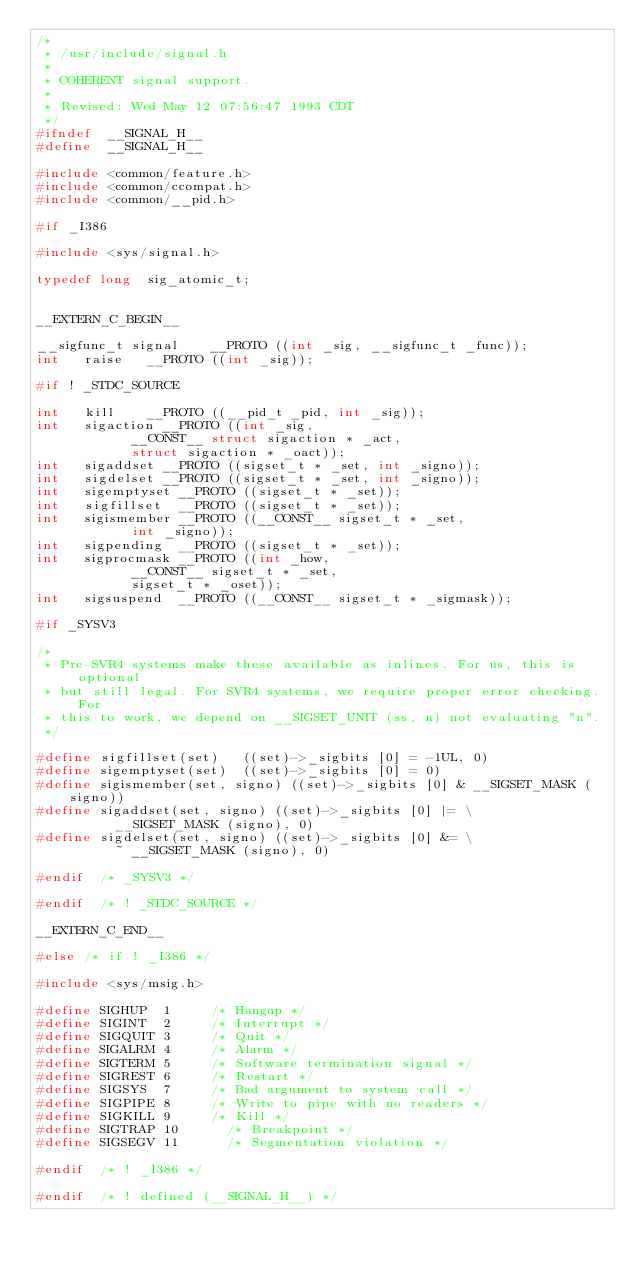Convert code to text. <code><loc_0><loc_0><loc_500><loc_500><_C_>/*
 * /usr/include/signal.h
 *
 * COHERENT signal support.
 *
 * Revised: Wed May 12 07:56:47 1993 CDT
 */
#ifndef	 __SIGNAL_H__
#define	 __SIGNAL_H__

#include <common/feature.h>
#include <common/ccompat.h>
#include <common/__pid.h>

#if	_I386

#include <sys/signal.h>

typedef	long	sig_atomic_t;


__EXTERN_C_BEGIN__

__sigfunc_t	signal		__PROTO ((int _sig, __sigfunc_t _func));
int		raise		__PROTO ((int _sig));

#if	! _STDC_SOURCE

int		kill		__PROTO ((__pid_t _pid, int _sig));
int		sigaction	__PROTO ((int _sig,
					  __CONST__ struct sigaction * _act,
					  struct sigaction * _oact));
int		sigaddset	__PROTO ((sigset_t * _set, int _signo));
int		sigdelset	__PROTO ((sigset_t * _set, int _signo));
int		sigemptyset	__PROTO ((sigset_t * _set));
int		sigfillset	__PROTO ((sigset_t * _set));
int		sigismember	__PROTO ((__CONST__ sigset_t * _set,
					  int _signo));
int		sigpending	__PROTO ((sigset_t * _set));
int		sigprocmask	__PROTO ((int _how,
					  __CONST__ sigset_t * _set,
					  sigset_t * _oset));
int		sigsuspend	__PROTO ((__CONST__ sigset_t * _sigmask));

#if	_SYSV3

/*
 * Pre-SVR4 systems make these available as inlines. For us, this is optional
 * but still legal. For SVR4 systems, we require proper error checking. For
 * this to work, we depend on __SIGSET_UNIT (ss, n) not evaluating "n".
 */

#define	sigfillset(set)		((set)->_sigbits [0] = -1UL, 0)
#define	sigemptyset(set)	((set)->_sigbits [0] = 0)
#define	sigismember(set, signo)	((set)->_sigbits [0] & __SIGSET_MASK (signo))
#define sigaddset(set, signo)	((set)->_sigbits [0] |= \
					__SIGSET_MASK (signo), 0)
#define	sigdelset(set, signo)	((set)->_sigbits [0] &= \
					~ __SIGSET_MASK (signo), 0)

#endif	/* _SYSV3 */

#endif	/* ! _STDC_SOURCE */

__EXTERN_C_END__

#else	/* if ! _I386 */

#include <sys/msig.h>

#define SIGHUP	1			/* Hangup */
#define	SIGINT	2			/* Interrupt */
#define SIGQUIT	3			/* Quit */
#define SIGALRM	4			/* Alarm */
#define SIGTERM	5			/* Software termination signal */
#define SIGREST	6			/* Restart */
#define SIGSYS	7			/* Bad argument to system call */
#define	SIGPIPE	8			/* Write to pipe with no readers */
#define SIGKILL	9			/* Kill */
#define SIGTRAP	10			/* Breakpoint */
#define	SIGSEGV	11			/* Segmentation violation */

#endif	/* ! _I386 */

#endif	/* ! defined (__SIGNAL_H__) */
</code> 